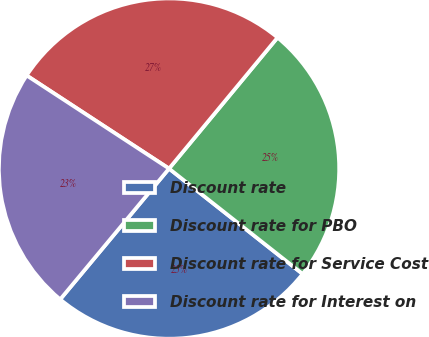Convert chart. <chart><loc_0><loc_0><loc_500><loc_500><pie_chart><fcel>Discount rate<fcel>Discount rate for PBO<fcel>Discount rate for Service Cost<fcel>Discount rate for Interest on<nl><fcel>25.42%<fcel>24.62%<fcel>26.79%<fcel>23.17%<nl></chart> 